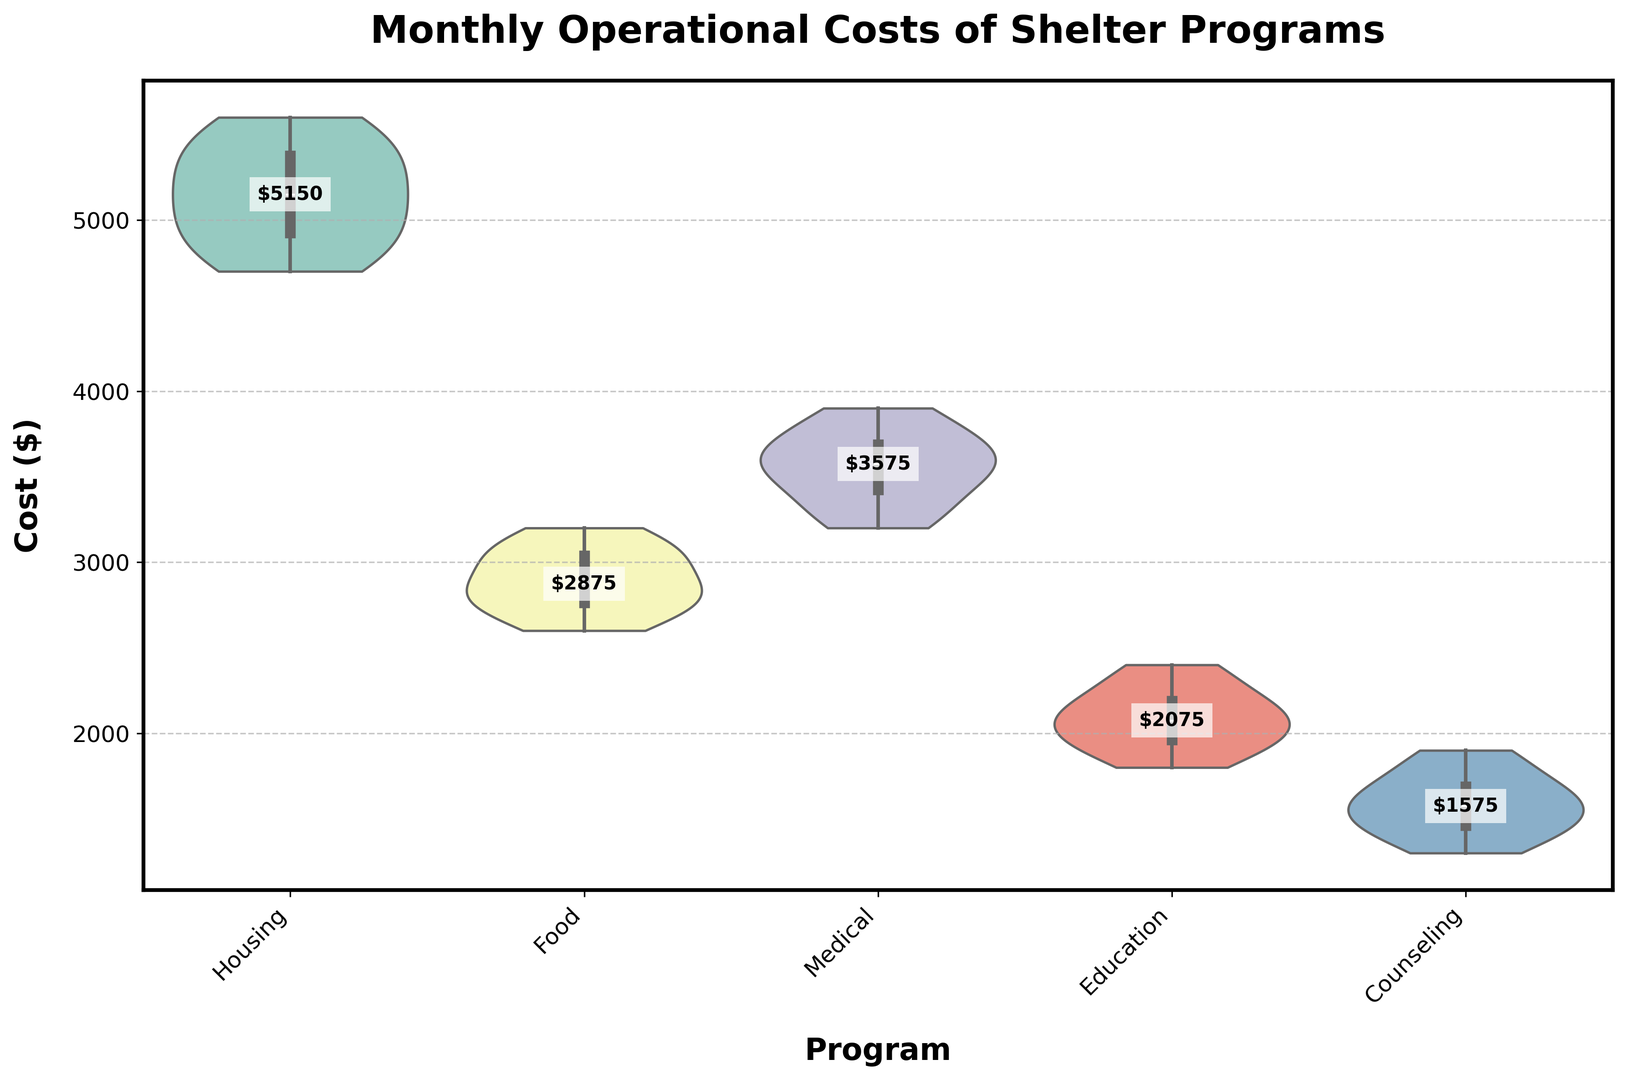What's the median monthly operational cost for the Housing program? To find the median, we need to sort the Housing program costs and find the middle value. The sorted values are: 4700, 4800, 4900, 5000, 5100, 5200, 5300, 5400, 5500, 5600. The median is the average of the 5th and 6th values (5100 and 5200). (5100 + 5200) / 2 = 5150
Answer: 5150 Which program has the highest median monthly cost? By looking at the violin plot, we compare the median labels we added. The program with the highest median is identified visually by the label: Medical with a median of 3550
Answer: Medical Which program exhibits the widest range of monthly costs? The range of each program can be assessed by looking at the width (spread) of the violin plots. Housing has the widest spread, ranging from 4700 to 5600, which is a 900 spread
Answer: Housing Are the costs for the Counseling program more or less variable than those for the Education program? To determine variability, we compare the spread of the data within each violin plot. Counseling has a spread of 1300 to 1900, while Education has a spread of 1800 to 2400. Both have a spread of 600. Thus, their variability is equal
Answer: Equal What is the median monthly operational cost for the Food program? From the violin plot, look at the median label within the Food distribution. The median for Food is 2850
Answer: 2850 How does the median monthly cost of the Education program compare to that of the Housing program? The median of the Education program is visually identified as 2100, and that of the Housing program is 5150. Comparing the two, 2100 is less than 5150. So, Housing is higher
Answer: Housing is higher Is the variation in monthly costs for the Medical program greater than that of the Food program? By comparing the spread of the violin plots: Medical ranges from 3200 to 3900 (spread of 700) and Food ranges from 2600 to 3200 (spread of 600). Medical has a greater variation
Answer: Medical What is the interquartile range (IQR) of the monthly costs for the Housing program? IQR is calculated as the difference between the third quartile (Q3) and the first quartile (Q1). From the violin plot’s internal box (representing IQR), approximate Q3 (5300) and Q1 (4900). IQR = 5300 - 4900 = 400
Answer: 400 